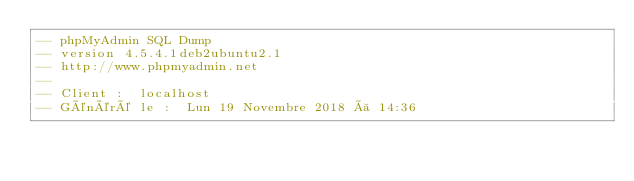<code> <loc_0><loc_0><loc_500><loc_500><_SQL_>-- phpMyAdmin SQL Dump
-- version 4.5.4.1deb2ubuntu2.1
-- http://www.phpmyadmin.net
--
-- Client :  localhost
-- Généré le :  Lun 19 Novembre 2018 à 14:36</code> 